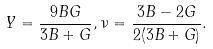Convert formula to latex. <formula><loc_0><loc_0><loc_500><loc_500>Y = \frac { 9 B G } { 3 B + G } , \nu = \frac { 3 B - 2 G } { 2 ( 3 B + G ) } .</formula> 